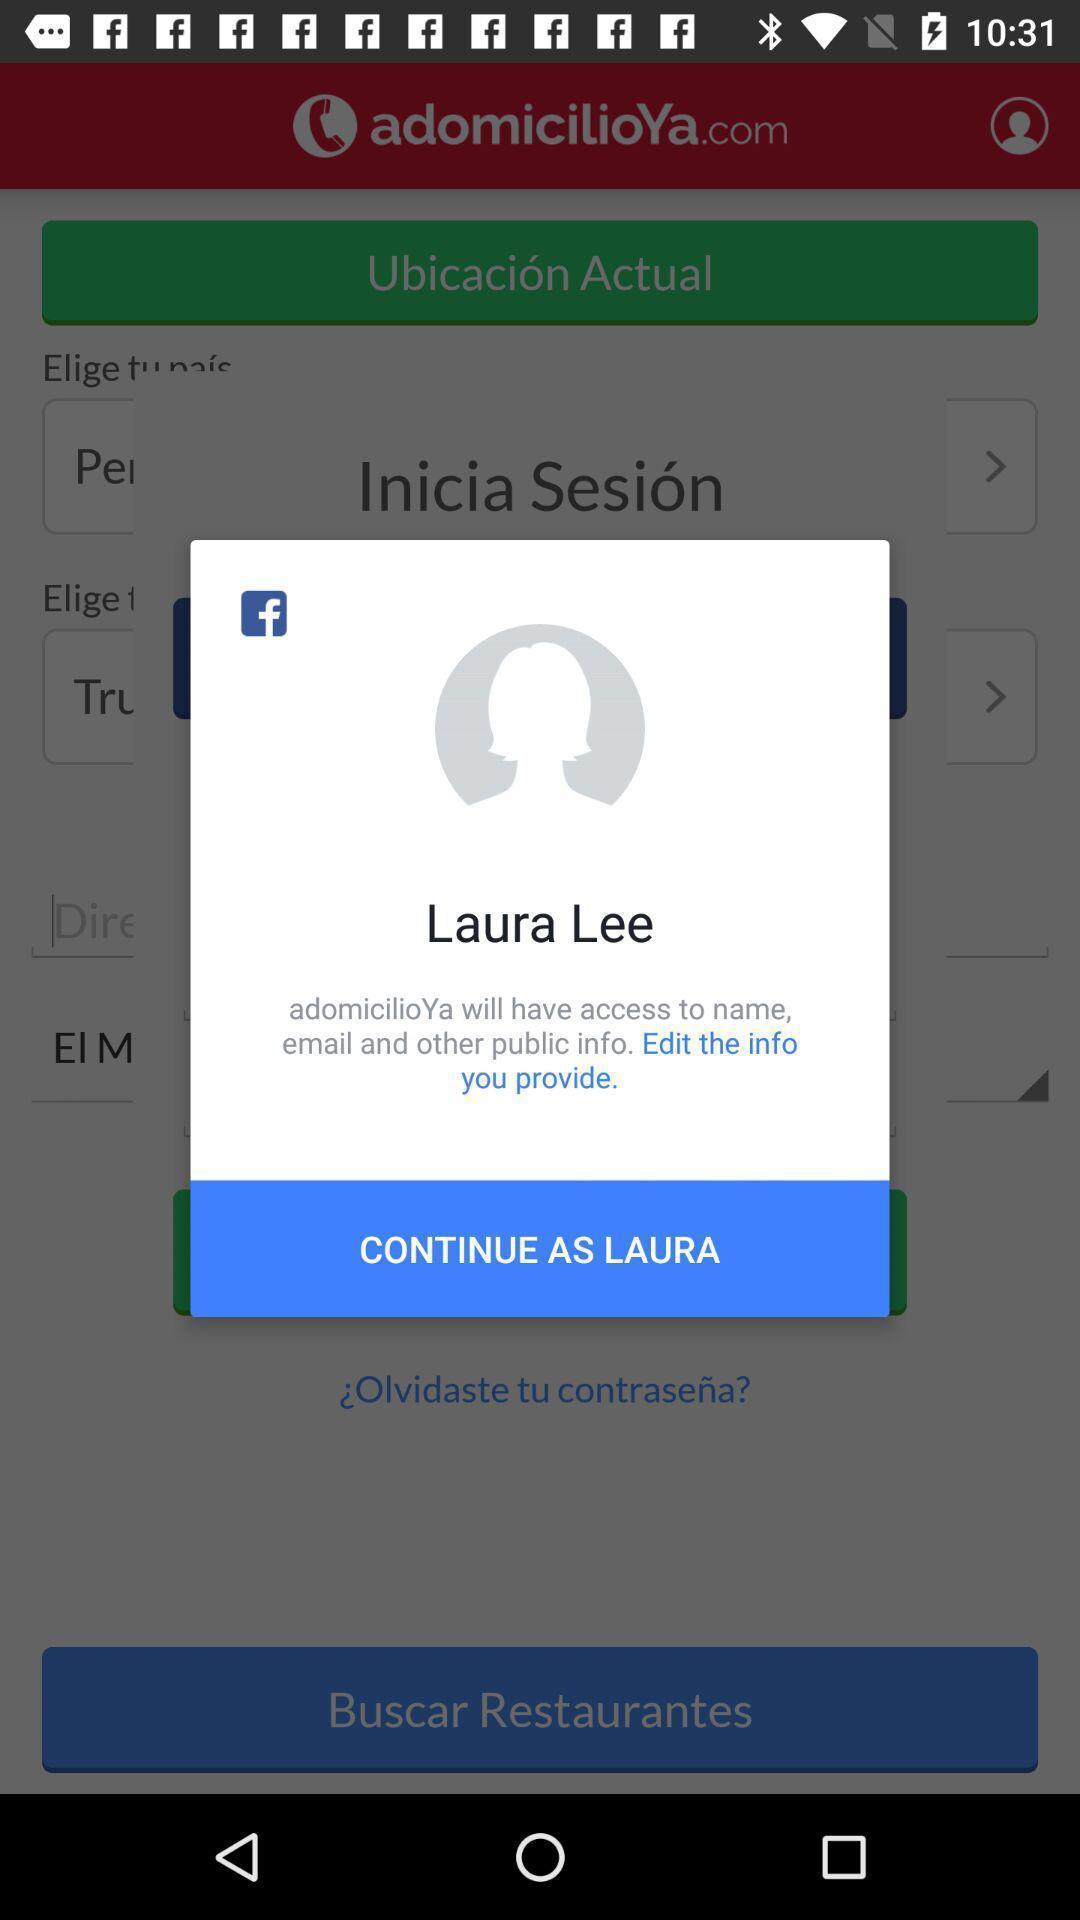Tell me about the visual elements in this screen capture. Pop-up shows to continue as for the application. 